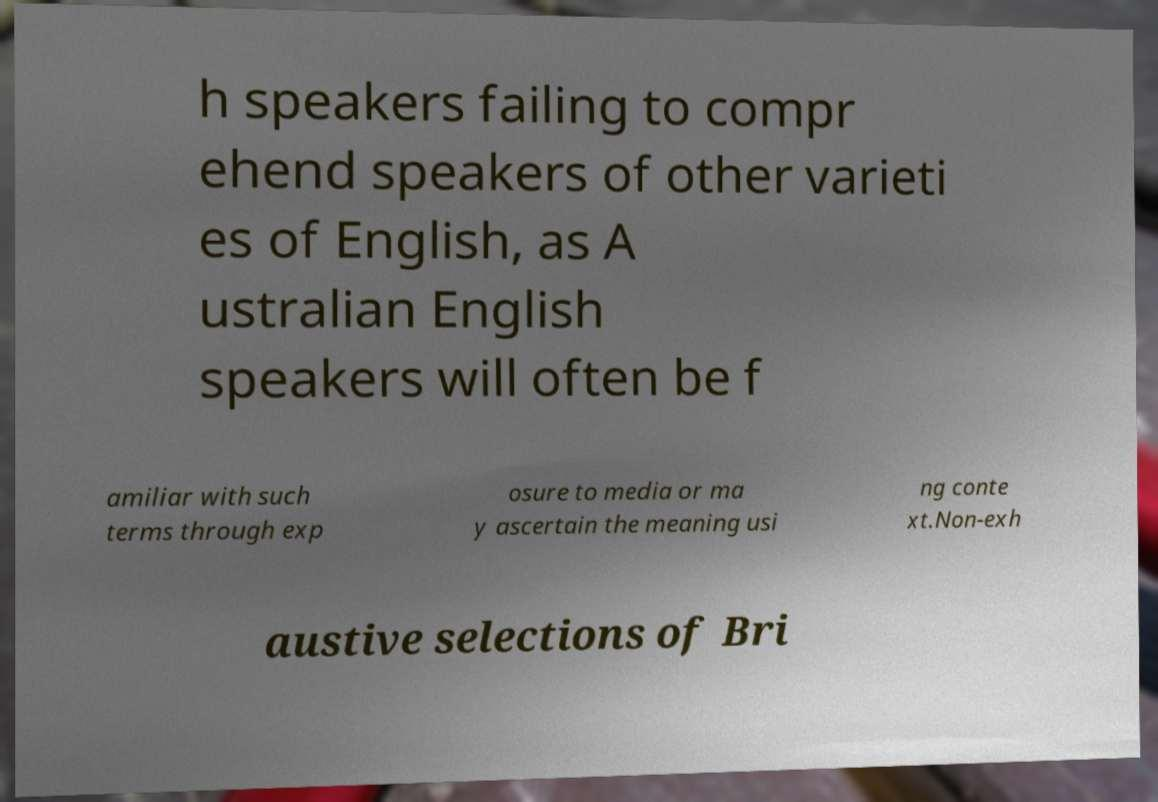Could you extract and type out the text from this image? h speakers failing to compr ehend speakers of other varieti es of English, as A ustralian English speakers will often be f amiliar with such terms through exp osure to media or ma y ascertain the meaning usi ng conte xt.Non-exh austive selections of Bri 